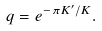<formula> <loc_0><loc_0><loc_500><loc_500>q = e ^ { - \pi K ^ { \prime } / K } .</formula> 